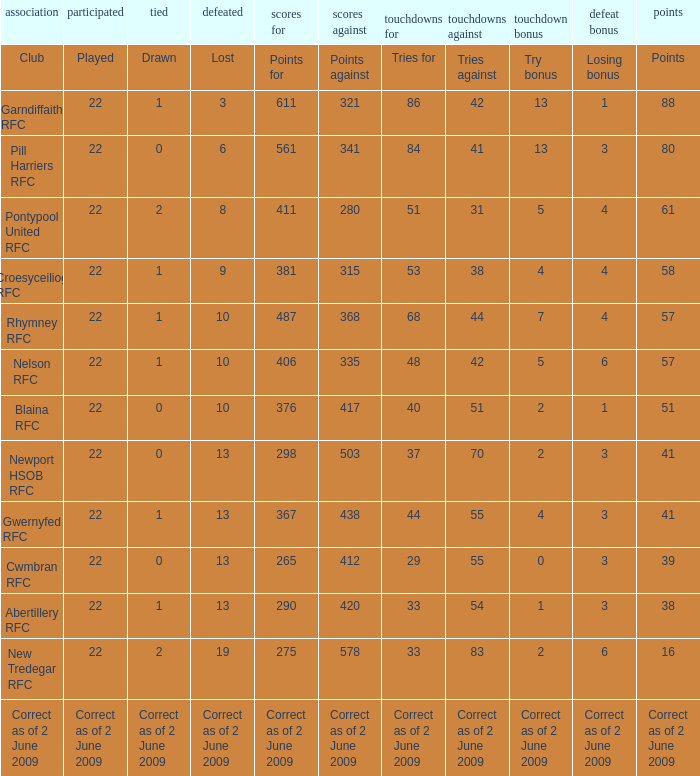Could you help me parse every detail presented in this table? {'header': ['association', 'participated', 'tied', 'defeated', 'scores for', 'scores against', 'touchdowns for', 'touchdowns against', 'touchdown bonus', 'defeat bonus', 'points'], 'rows': [['Club', 'Played', 'Drawn', 'Lost', 'Points for', 'Points against', 'Tries for', 'Tries against', 'Try bonus', 'Losing bonus', 'Points'], ['Garndiffaith RFC', '22', '1', '3', '611', '321', '86', '42', '13', '1', '88'], ['Pill Harriers RFC', '22', '0', '6', '561', '341', '84', '41', '13', '3', '80'], ['Pontypool United RFC', '22', '2', '8', '411', '280', '51', '31', '5', '4', '61'], ['Croesyceiliog RFC', '22', '1', '9', '381', '315', '53', '38', '4', '4', '58'], ['Rhymney RFC', '22', '1', '10', '487', '368', '68', '44', '7', '4', '57'], ['Nelson RFC', '22', '1', '10', '406', '335', '48', '42', '5', '6', '57'], ['Blaina RFC', '22', '0', '10', '376', '417', '40', '51', '2', '1', '51'], ['Newport HSOB RFC', '22', '0', '13', '298', '503', '37', '70', '2', '3', '41'], ['Gwernyfed RFC', '22', '1', '13', '367', '438', '44', '55', '4', '3', '41'], ['Cwmbran RFC', '22', '0', '13', '265', '412', '29', '55', '0', '3', '39'], ['Abertillery RFC', '22', '1', '13', '290', '420', '33', '54', '1', '3', '38'], ['New Tredegar RFC', '22', '2', '19', '275', '578', '33', '83', '2', '6', '16'], ['Correct as of 2 June 2009', 'Correct as of 2 June 2009', 'Correct as of 2 June 2009', 'Correct as of 2 June 2009', 'Correct as of 2 June 2009', 'Correct as of 2 June 2009', 'Correct as of 2 June 2009', 'Correct as of 2 June 2009', 'Correct as of 2 June 2009', 'Correct as of 2 June 2009', 'Correct as of 2 June 2009']]} How many tries did the club with a try bonus of correct as of 2 June 2009 have? Correct as of 2 June 2009. 